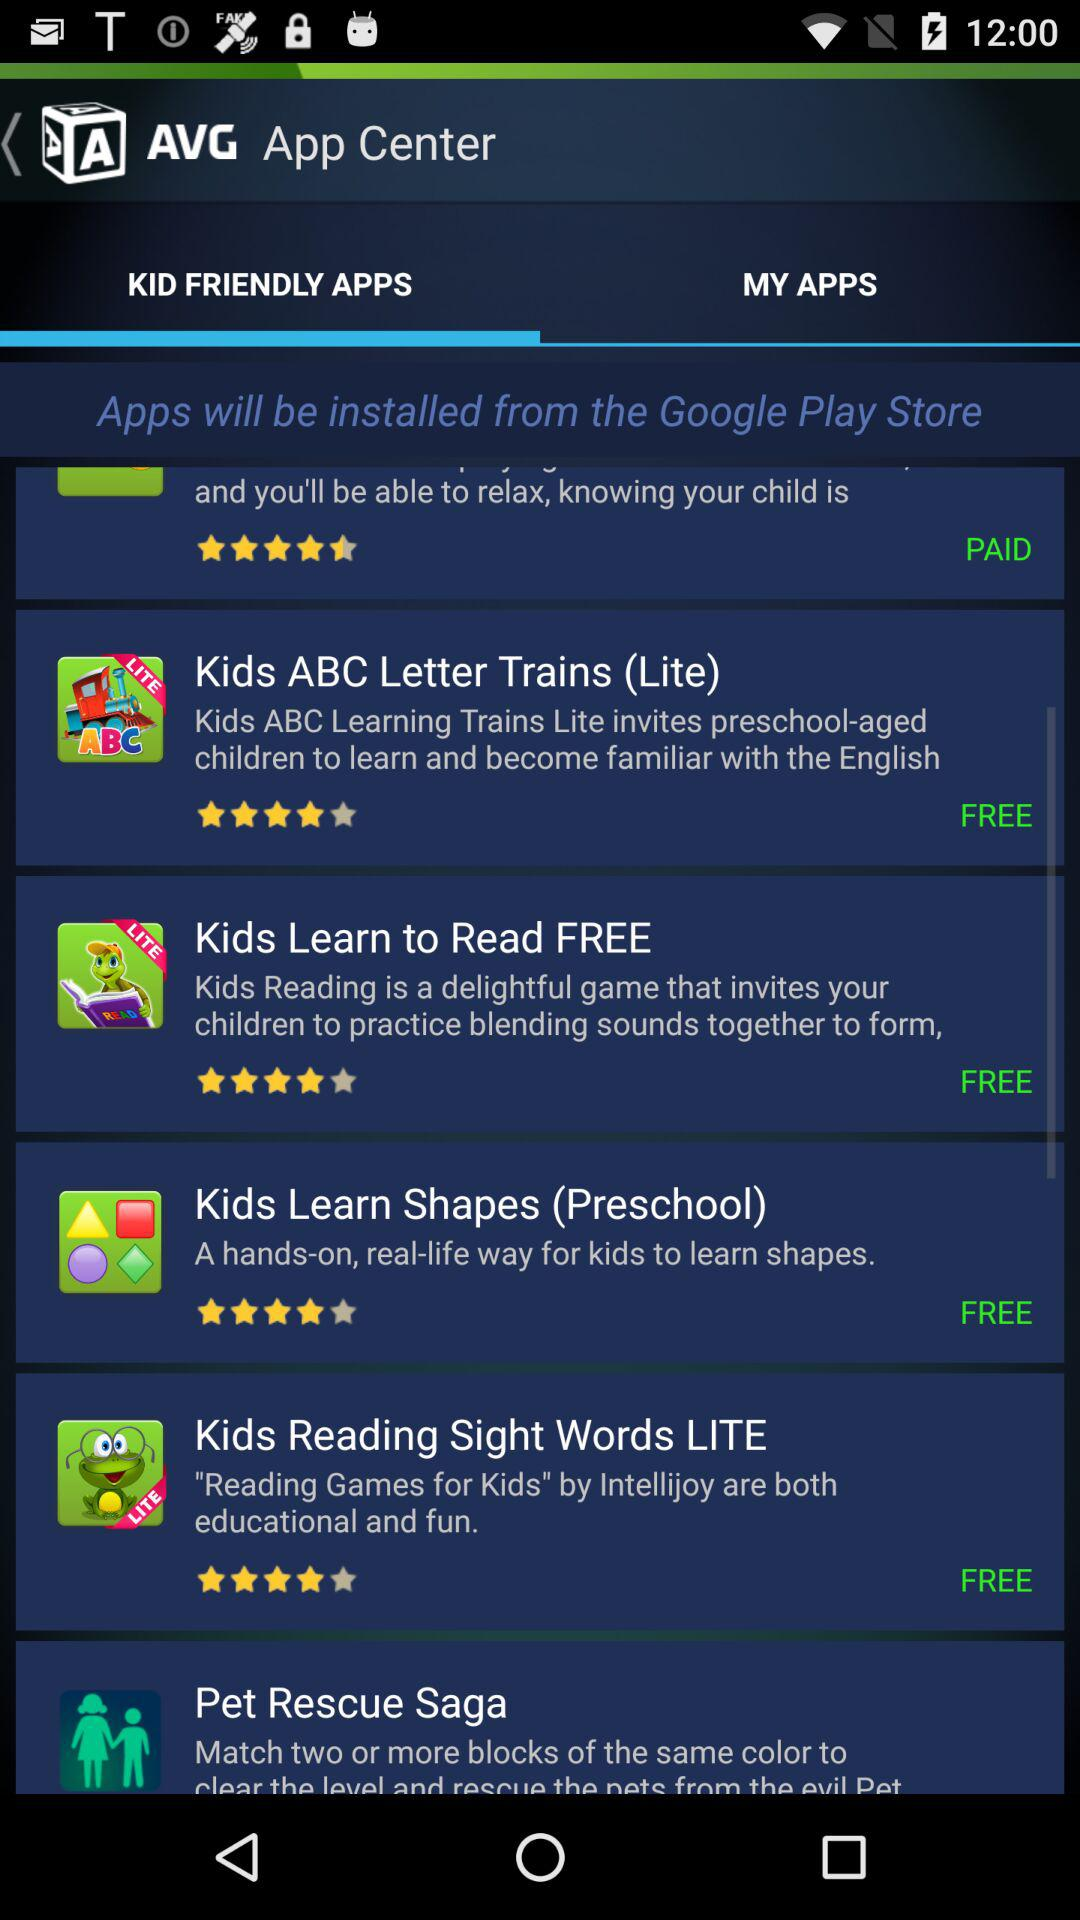Which tab am I on? You are on the "KID FRIENDLY APPS" tab. 